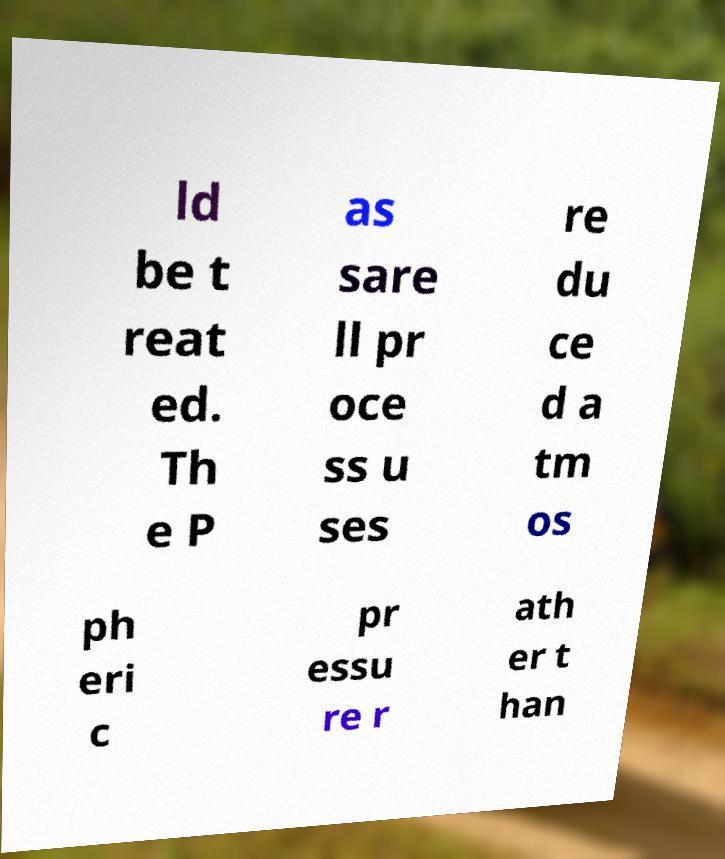Could you assist in decoding the text presented in this image and type it out clearly? ld be t reat ed. Th e P as sare ll pr oce ss u ses re du ce d a tm os ph eri c pr essu re r ath er t han 